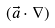Convert formula to latex. <formula><loc_0><loc_0><loc_500><loc_500>( \vec { a } \cdot \nabla )</formula> 